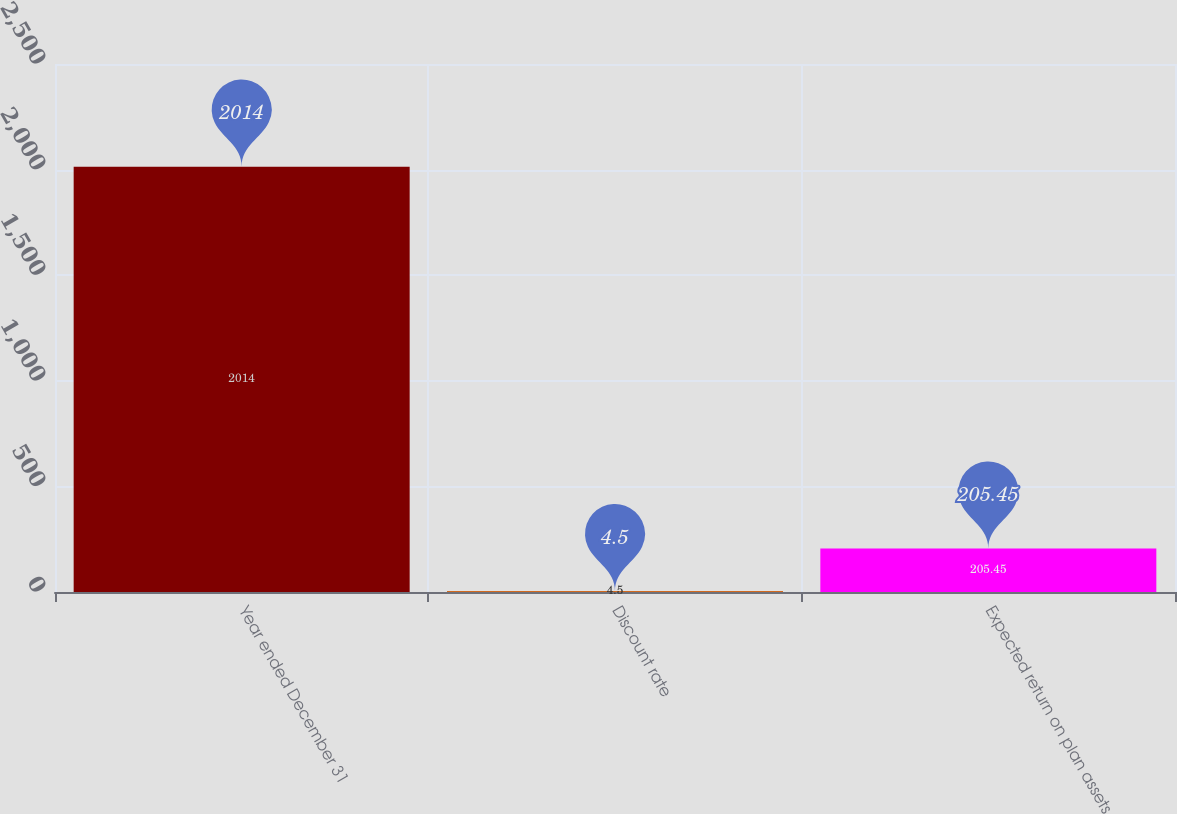<chart> <loc_0><loc_0><loc_500><loc_500><bar_chart><fcel>Year ended December 31<fcel>Discount rate<fcel>Expected return on plan assets<nl><fcel>2014<fcel>4.5<fcel>205.45<nl></chart> 